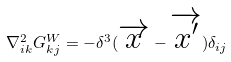Convert formula to latex. <formula><loc_0><loc_0><loc_500><loc_500>\nabla _ { i k } ^ { 2 } G ^ { W } _ { k j } = - \delta ^ { 3 } ( \overrightarrow { x } - \overrightarrow { x ^ { \prime } } ) \delta _ { i j }</formula> 